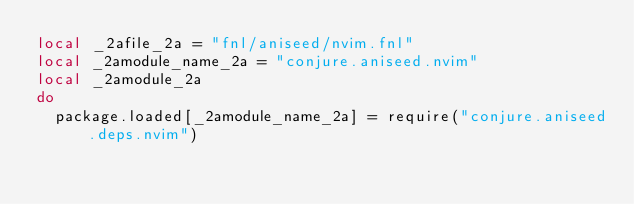Convert code to text. <code><loc_0><loc_0><loc_500><loc_500><_Lua_>local _2afile_2a = "fnl/aniseed/nvim.fnl"
local _2amodule_name_2a = "conjure.aniseed.nvim"
local _2amodule_2a
do
  package.loaded[_2amodule_name_2a] = require("conjure.aniseed.deps.nvim")</code> 